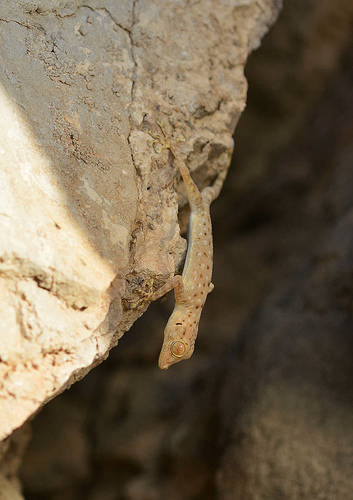<image>
Is the lizard behind the rock? No. The lizard is not behind the rock. From this viewpoint, the lizard appears to be positioned elsewhere in the scene. 